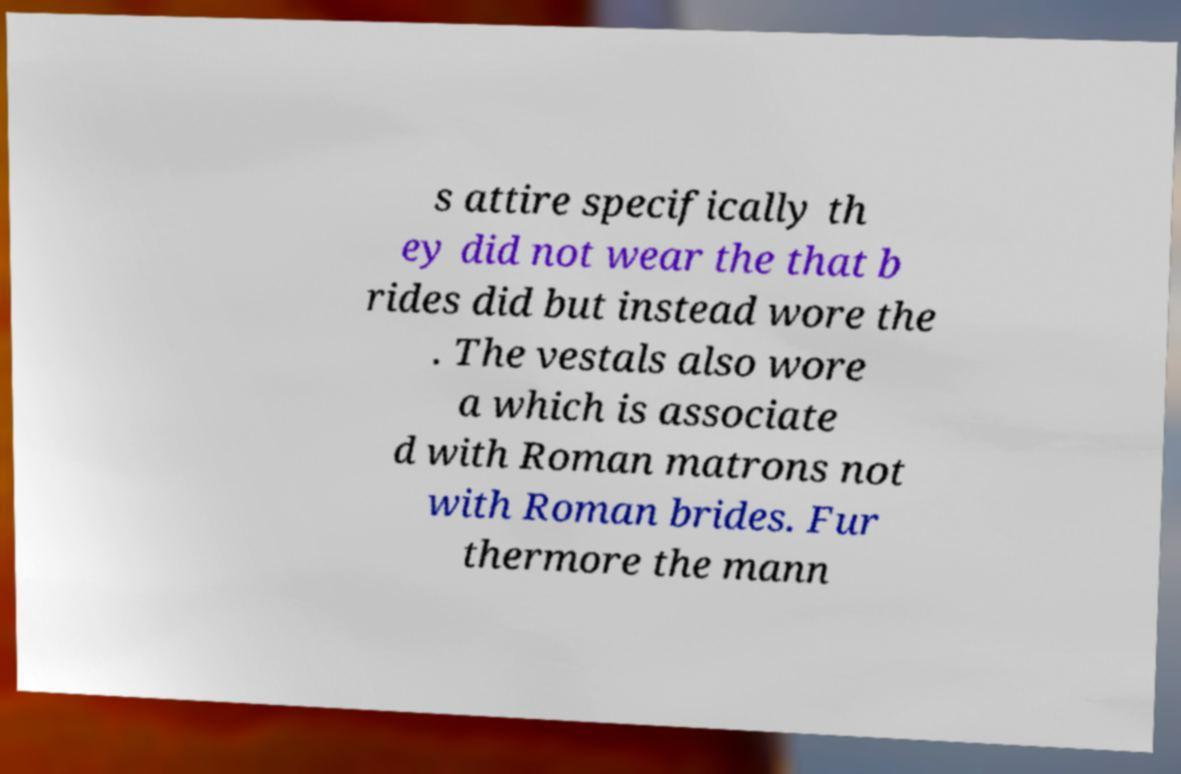For documentation purposes, I need the text within this image transcribed. Could you provide that? s attire specifically th ey did not wear the that b rides did but instead wore the . The vestals also wore a which is associate d with Roman matrons not with Roman brides. Fur thermore the mann 